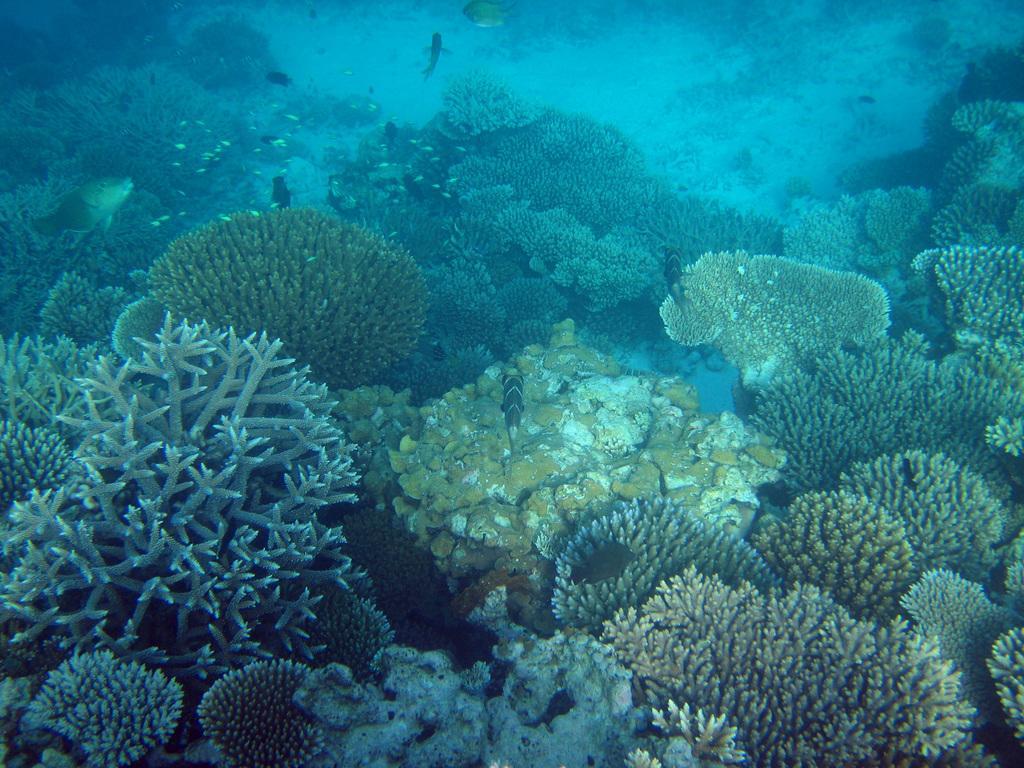How would you summarize this image in a sentence or two? In this picture we can see corals and fishes underwater. 